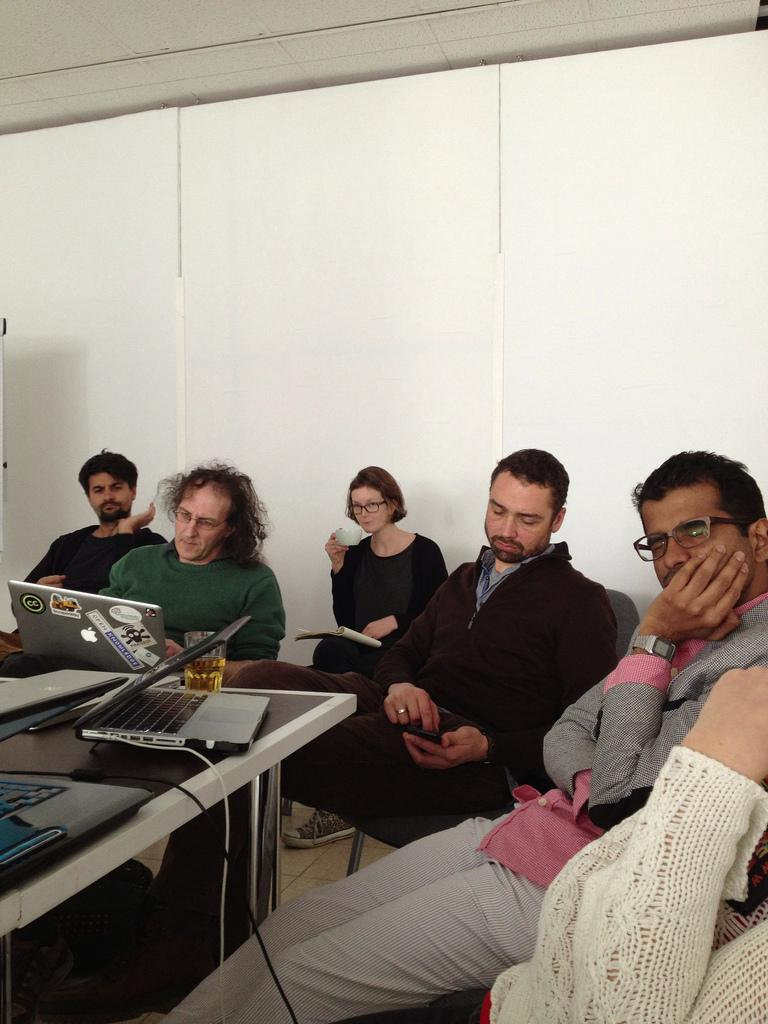Where is the image taken? The image is taken in a room. What furniture is present in the room? There is a table and chairs in the room. What are the people in the image doing? People are sitting on the chairs. Where is the table located in the room? The table is in the bottom left corner of the room. What electronic devices are on the table? There are laptops placed on the table. What type of verse can be heard being recited in the image? There is no indication in the image that any verse is being recited, so it cannot be determined from the picture. 